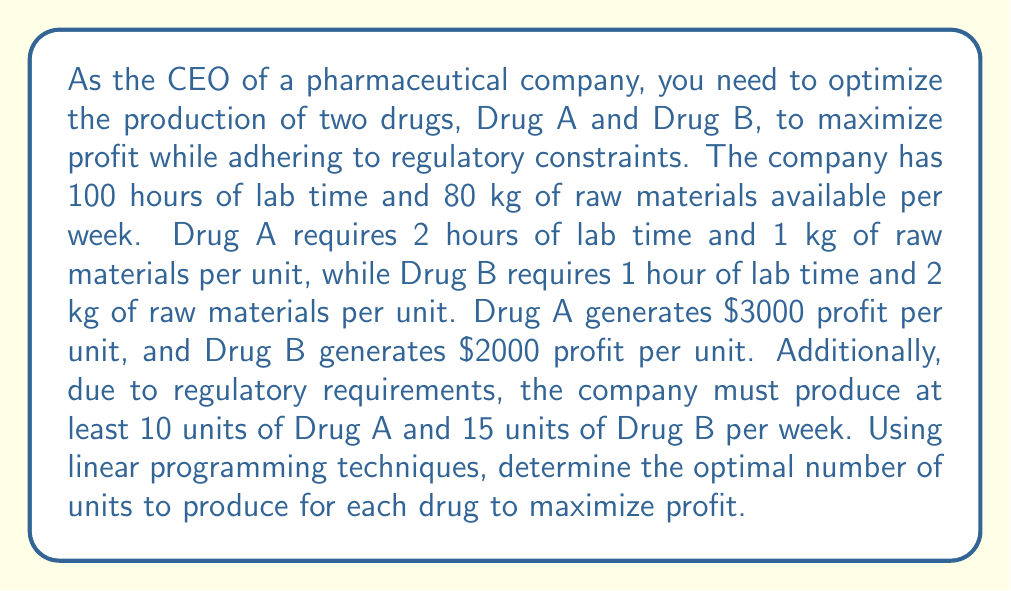Teach me how to tackle this problem. Let's approach this problem using linear programming:

1. Define variables:
   Let $x$ be the number of units of Drug A
   Let $y$ be the number of units of Drug B

2. Objective function (maximize profit):
   $$\text{Maximize } Z = 3000x + 2000y$$

3. Constraints:
   Lab time: $2x + y \leq 100$
   Raw materials: $x + 2y \leq 80$
   Regulatory minimum for Drug A: $x \geq 10$
   Regulatory minimum for Drug B: $y \geq 15$
   Non-negativity: $x \geq 0, y \geq 0$

4. Graph the constraints:
   [asy]
   import graph;
   size(200);
   xaxis("Drug A", 0, 60);
   yaxis("Drug B", 0, 80);
   draw((0,50)--(50,0), blue);
   draw((0,40)--(80,0), red);
   draw((10,0)--(10,80), green);
   draw((0,15)--(80,15), purple);
   label("Lab time", (25,25), blue);
   label("Raw materials", (40,20), red);
   label("Drug A min", (10,40), green);
   label("Drug B min", (40,15), purple);
   fill((10,15)--(10,40)--(35,15)--cycle, lightgray);
   [/asy]

5. Identify feasible region:
   The shaded area represents the feasible region.

6. Find corner points:
   (10, 15), (10, 40), (35, 15)

7. Evaluate objective function at corner points:
   At (10, 15): $Z = 3000(10) + 2000(15) = 60,000$
   At (10, 40): $Z = 3000(10) + 2000(40) = 110,000$
   At (35, 15): $Z = 3000(35) + 2000(15) = 135,000$

8. Choose the optimal solution:
   The maximum profit occurs at (35, 15), which means producing 35 units of Drug A and 15 units of Drug B.
Answer: The optimal allocation is to produce 35 units of Drug A and 15 units of Drug B, resulting in a maximum profit of $135,000 per week. 